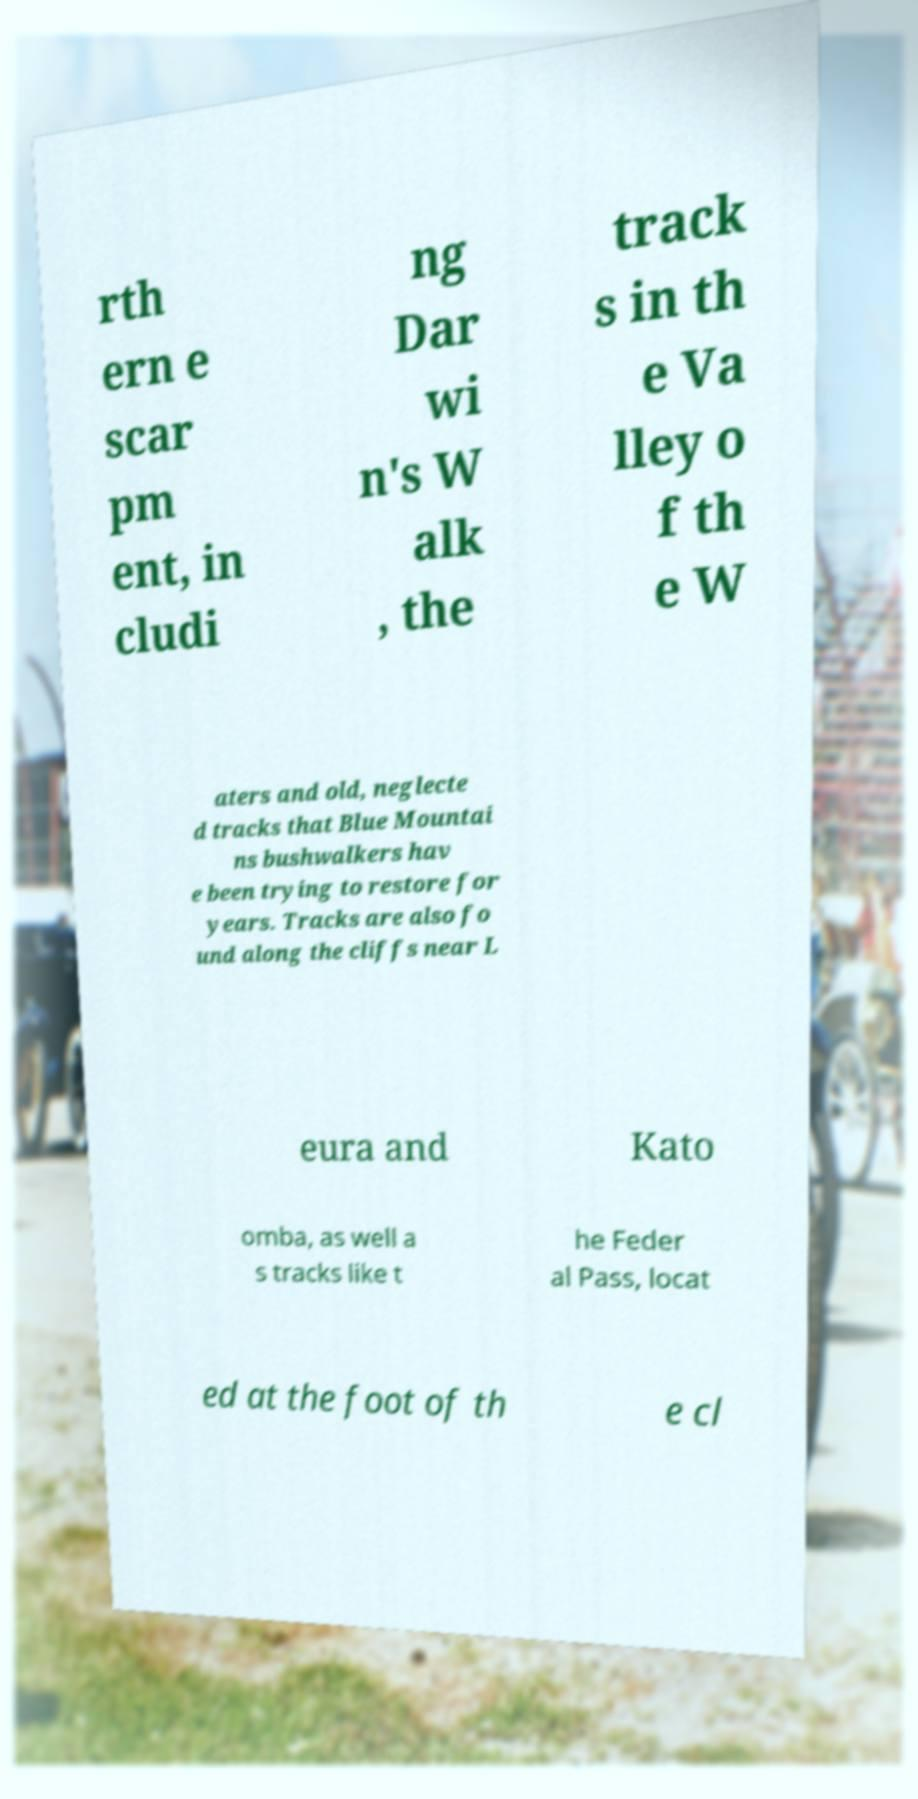Could you assist in decoding the text presented in this image and type it out clearly? rth ern e scar pm ent, in cludi ng Dar wi n's W alk , the track s in th e Va lley o f th e W aters and old, neglecte d tracks that Blue Mountai ns bushwalkers hav e been trying to restore for years. Tracks are also fo und along the cliffs near L eura and Kato omba, as well a s tracks like t he Feder al Pass, locat ed at the foot of th e cl 